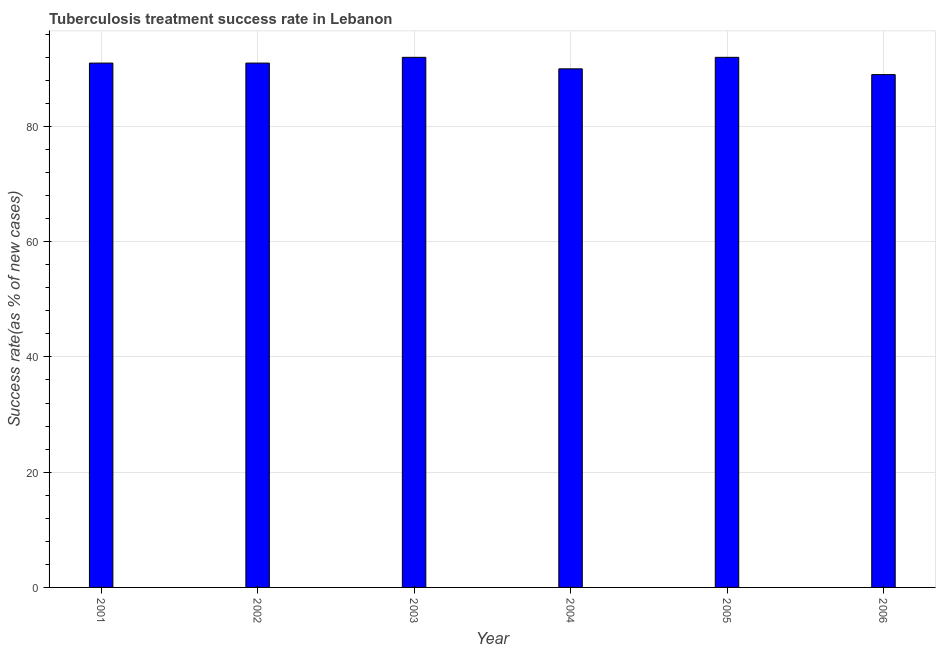Does the graph contain any zero values?
Your answer should be compact. No. What is the title of the graph?
Make the answer very short. Tuberculosis treatment success rate in Lebanon. What is the label or title of the Y-axis?
Offer a terse response. Success rate(as % of new cases). What is the tuberculosis treatment success rate in 2003?
Provide a succinct answer. 92. Across all years, what is the maximum tuberculosis treatment success rate?
Your answer should be compact. 92. Across all years, what is the minimum tuberculosis treatment success rate?
Keep it short and to the point. 89. In which year was the tuberculosis treatment success rate maximum?
Provide a succinct answer. 2003. In which year was the tuberculosis treatment success rate minimum?
Your response must be concise. 2006. What is the sum of the tuberculosis treatment success rate?
Make the answer very short. 545. What is the difference between the tuberculosis treatment success rate in 2003 and 2004?
Keep it short and to the point. 2. What is the median tuberculosis treatment success rate?
Offer a terse response. 91. Do a majority of the years between 2002 and 2003 (inclusive) have tuberculosis treatment success rate greater than 68 %?
Your response must be concise. Yes. Is the difference between the tuberculosis treatment success rate in 2001 and 2003 greater than the difference between any two years?
Give a very brief answer. No. What is the difference between the highest and the second highest tuberculosis treatment success rate?
Provide a succinct answer. 0. How many bars are there?
Make the answer very short. 6. How many years are there in the graph?
Offer a very short reply. 6. What is the Success rate(as % of new cases) of 2001?
Offer a terse response. 91. What is the Success rate(as % of new cases) in 2002?
Offer a terse response. 91. What is the Success rate(as % of new cases) of 2003?
Your answer should be compact. 92. What is the Success rate(as % of new cases) in 2005?
Provide a succinct answer. 92. What is the Success rate(as % of new cases) in 2006?
Your answer should be very brief. 89. What is the difference between the Success rate(as % of new cases) in 2001 and 2003?
Make the answer very short. -1. What is the difference between the Success rate(as % of new cases) in 2001 and 2004?
Your response must be concise. 1. What is the difference between the Success rate(as % of new cases) in 2001 and 2006?
Give a very brief answer. 2. What is the difference between the Success rate(as % of new cases) in 2002 and 2003?
Your answer should be very brief. -1. What is the difference between the Success rate(as % of new cases) in 2002 and 2004?
Keep it short and to the point. 1. What is the difference between the Success rate(as % of new cases) in 2002 and 2006?
Make the answer very short. 2. What is the difference between the Success rate(as % of new cases) in 2003 and 2005?
Make the answer very short. 0. What is the difference between the Success rate(as % of new cases) in 2003 and 2006?
Your answer should be very brief. 3. What is the difference between the Success rate(as % of new cases) in 2004 and 2005?
Offer a terse response. -2. What is the difference between the Success rate(as % of new cases) in 2004 and 2006?
Make the answer very short. 1. What is the ratio of the Success rate(as % of new cases) in 2001 to that in 2002?
Give a very brief answer. 1. What is the ratio of the Success rate(as % of new cases) in 2001 to that in 2003?
Offer a terse response. 0.99. What is the ratio of the Success rate(as % of new cases) in 2001 to that in 2005?
Your response must be concise. 0.99. What is the ratio of the Success rate(as % of new cases) in 2002 to that in 2004?
Your response must be concise. 1.01. What is the ratio of the Success rate(as % of new cases) in 2002 to that in 2006?
Make the answer very short. 1.02. What is the ratio of the Success rate(as % of new cases) in 2003 to that in 2006?
Give a very brief answer. 1.03. What is the ratio of the Success rate(as % of new cases) in 2004 to that in 2005?
Offer a very short reply. 0.98. What is the ratio of the Success rate(as % of new cases) in 2005 to that in 2006?
Offer a terse response. 1.03. 